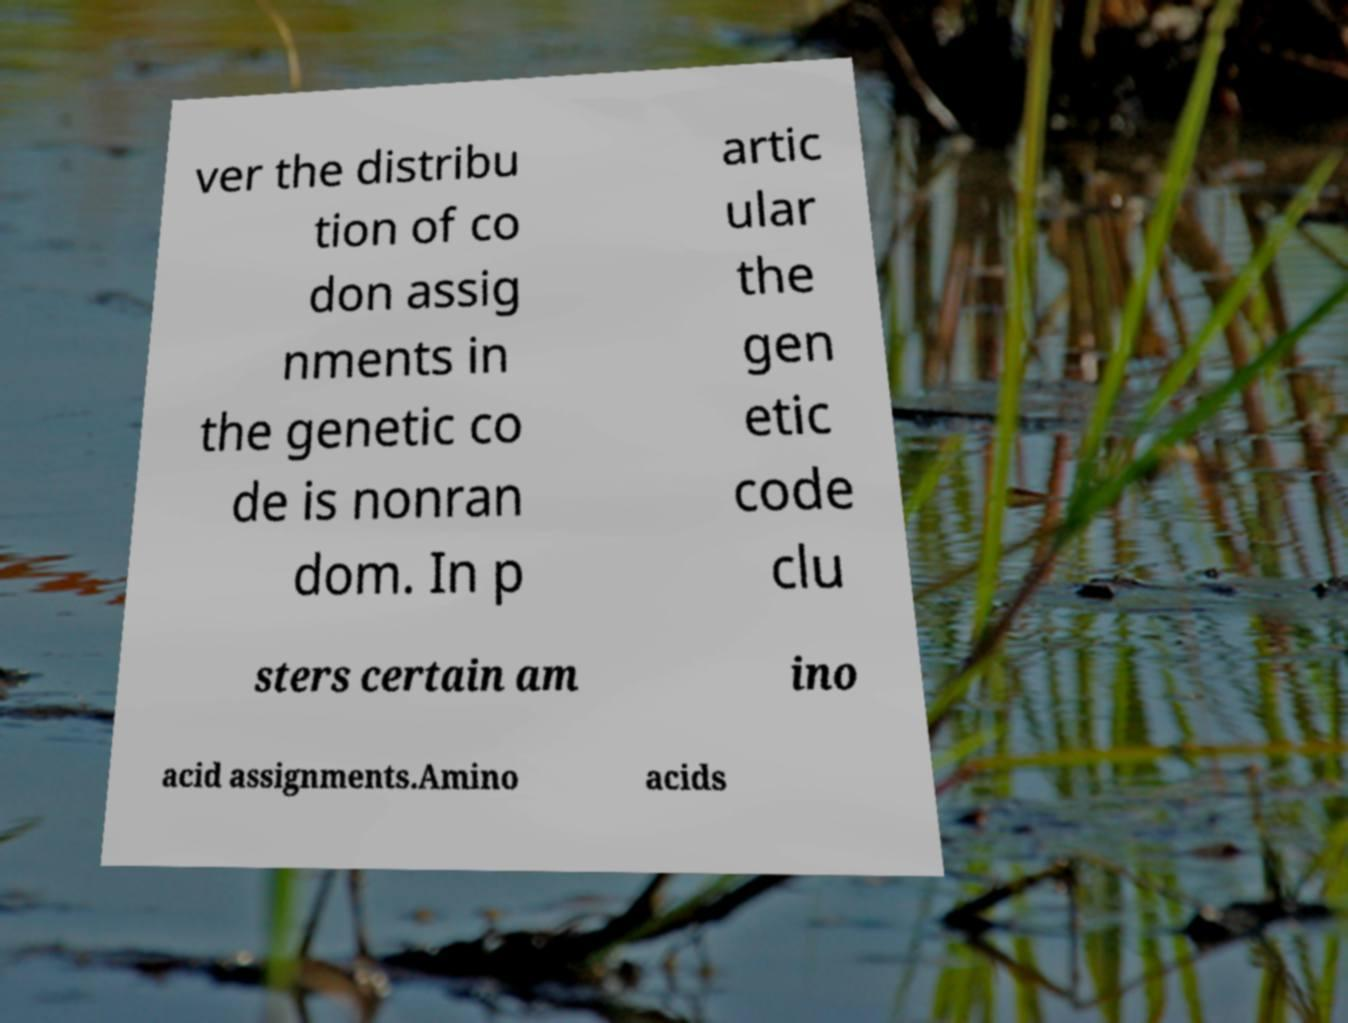Can you read and provide the text displayed in the image?This photo seems to have some interesting text. Can you extract and type it out for me? ver the distribu tion of co don assig nments in the genetic co de is nonran dom. In p artic ular the gen etic code clu sters certain am ino acid assignments.Amino acids 